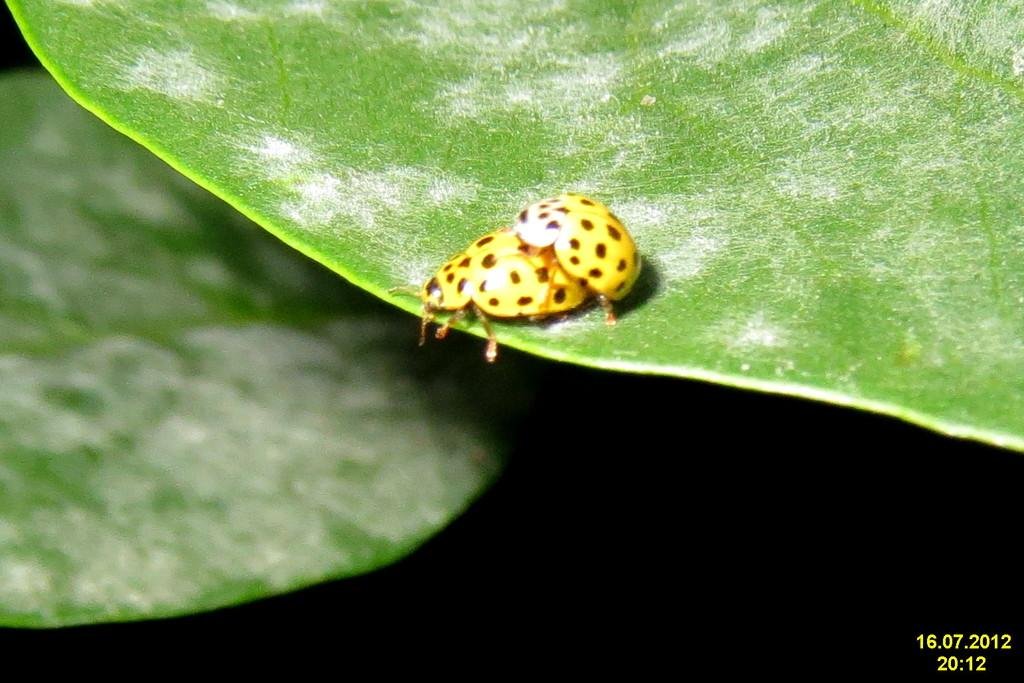What is the main subject in the center of the image? There is a bug in the center of the image. Where is the bug located? The bug is on a leaf. Can you describe the background of the image? There is another leaf in the background of the image. What type of guide can be seen helping the bug in the image? There is no guide present in the image, and the bug is not interacting with any other subject or object. 